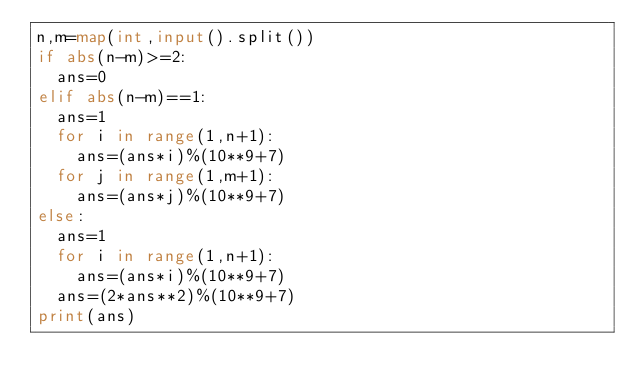<code> <loc_0><loc_0><loc_500><loc_500><_Python_>n,m=map(int,input().split())
if abs(n-m)>=2:
  ans=0
elif abs(n-m)==1:
  ans=1
  for i in range(1,n+1):
    ans=(ans*i)%(10**9+7)
  for j in range(1,m+1):
    ans=(ans*j)%(10**9+7)
else:
  ans=1
  for i in range(1,n+1):
    ans=(ans*i)%(10**9+7)
  ans=(2*ans**2)%(10**9+7)
print(ans)</code> 